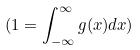<formula> <loc_0><loc_0><loc_500><loc_500>( 1 = \int _ { - \infty } ^ { \infty } g ( x ) d x )</formula> 